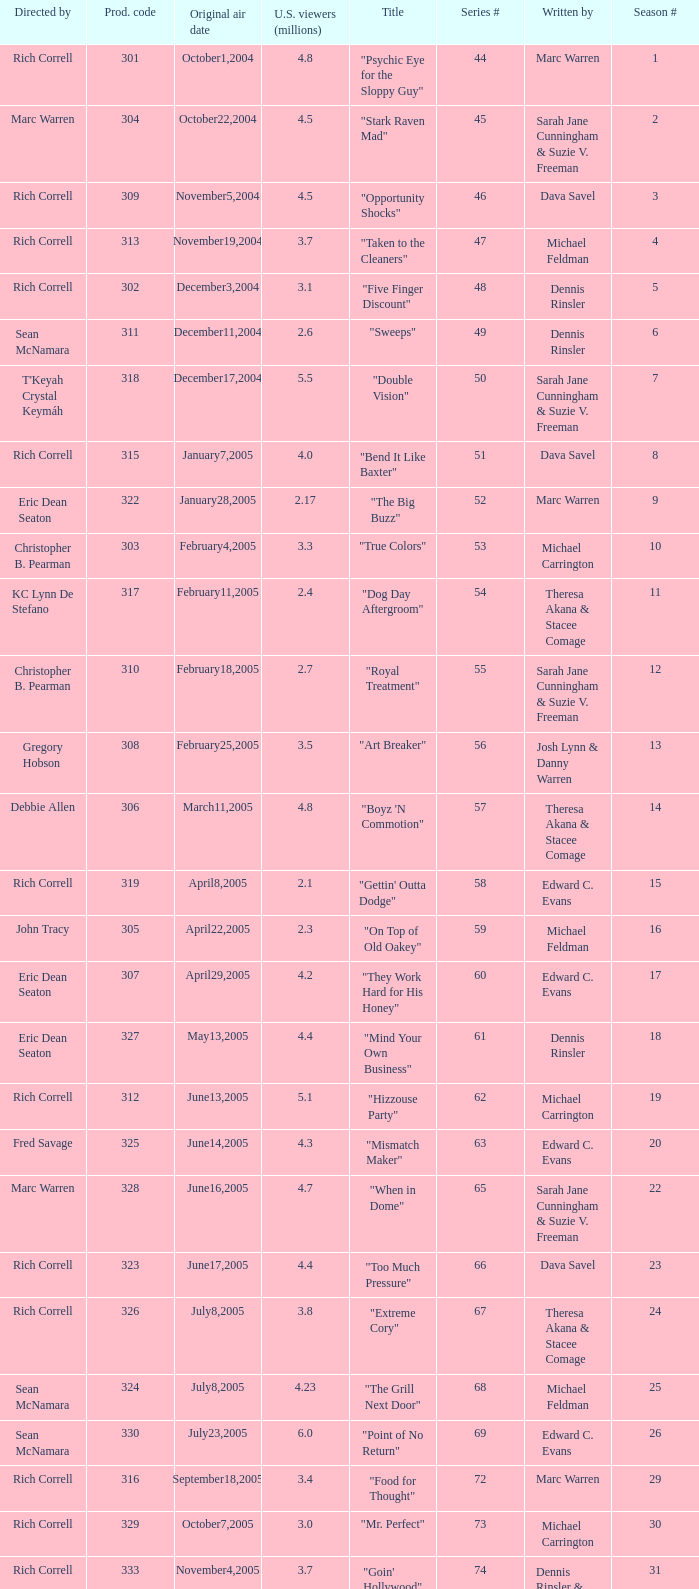What number episode in the season had a production code of 334? 32.0. 